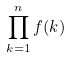<formula> <loc_0><loc_0><loc_500><loc_500>\prod _ { k = 1 } ^ { n } f ( k )</formula> 